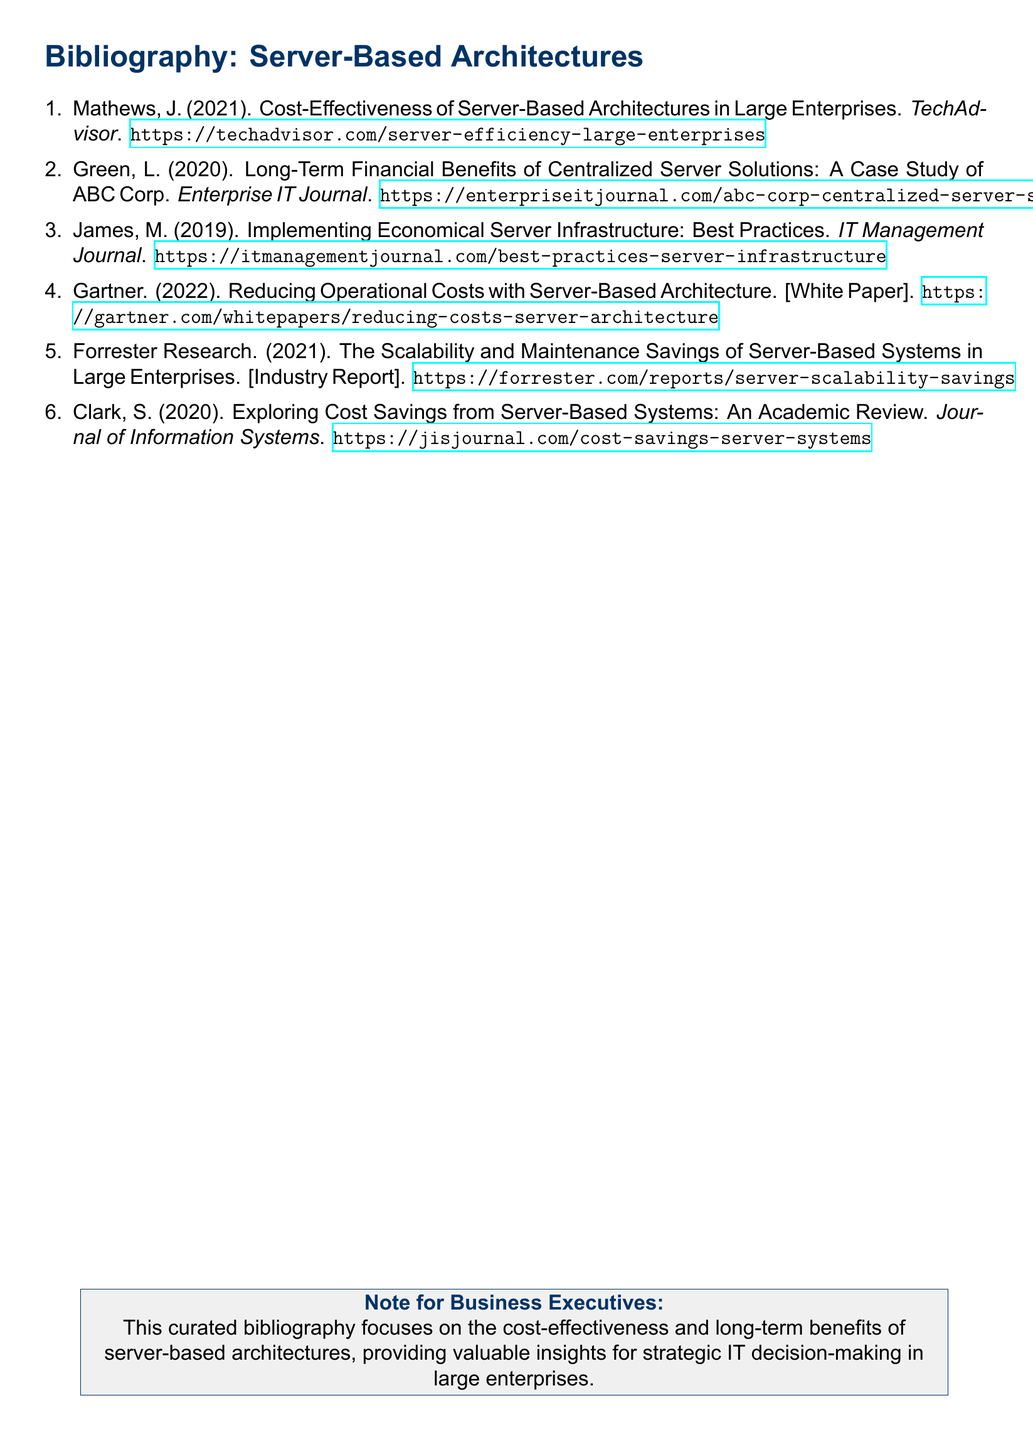What is the title of the first article? The first article is titled "Cost-Effectiveness of Server-Based Architectures in Large Enterprises."
Answer: Cost-Effectiveness of Server-Based Architectures in Large Enterprises Who is the author of the second entry? The author of the second entry is Green, L.
Answer: Green, L What year was the fifth document published? The fifth document was published in 2021.
Answer: 2021 What type of document is the fourth entry? The fourth entry is described as a white paper.
Answer: White Paper What is the main focus of the bibliography? The main focus of the bibliography is the cost-effectiveness and long-term benefits of server-based architectures.
Answer: Cost-effectiveness and long-term benefits of server-based architectures Which journal features the article on best practices for implementing server infrastructure? The article on best practices is featured in the IT Management Journal.
Answer: IT Management Journal How many entries are in the bibliography? There are six entries in the bibliography.
Answer: Six What is the URL for the case study about ABC Corp? The URL for the case study is https://enterpriseitjournal.com/abc-corp-centralized-server-solutions.
Answer: https://enterpriseitjournal.com/abc-corp-centralized-server-solutions 